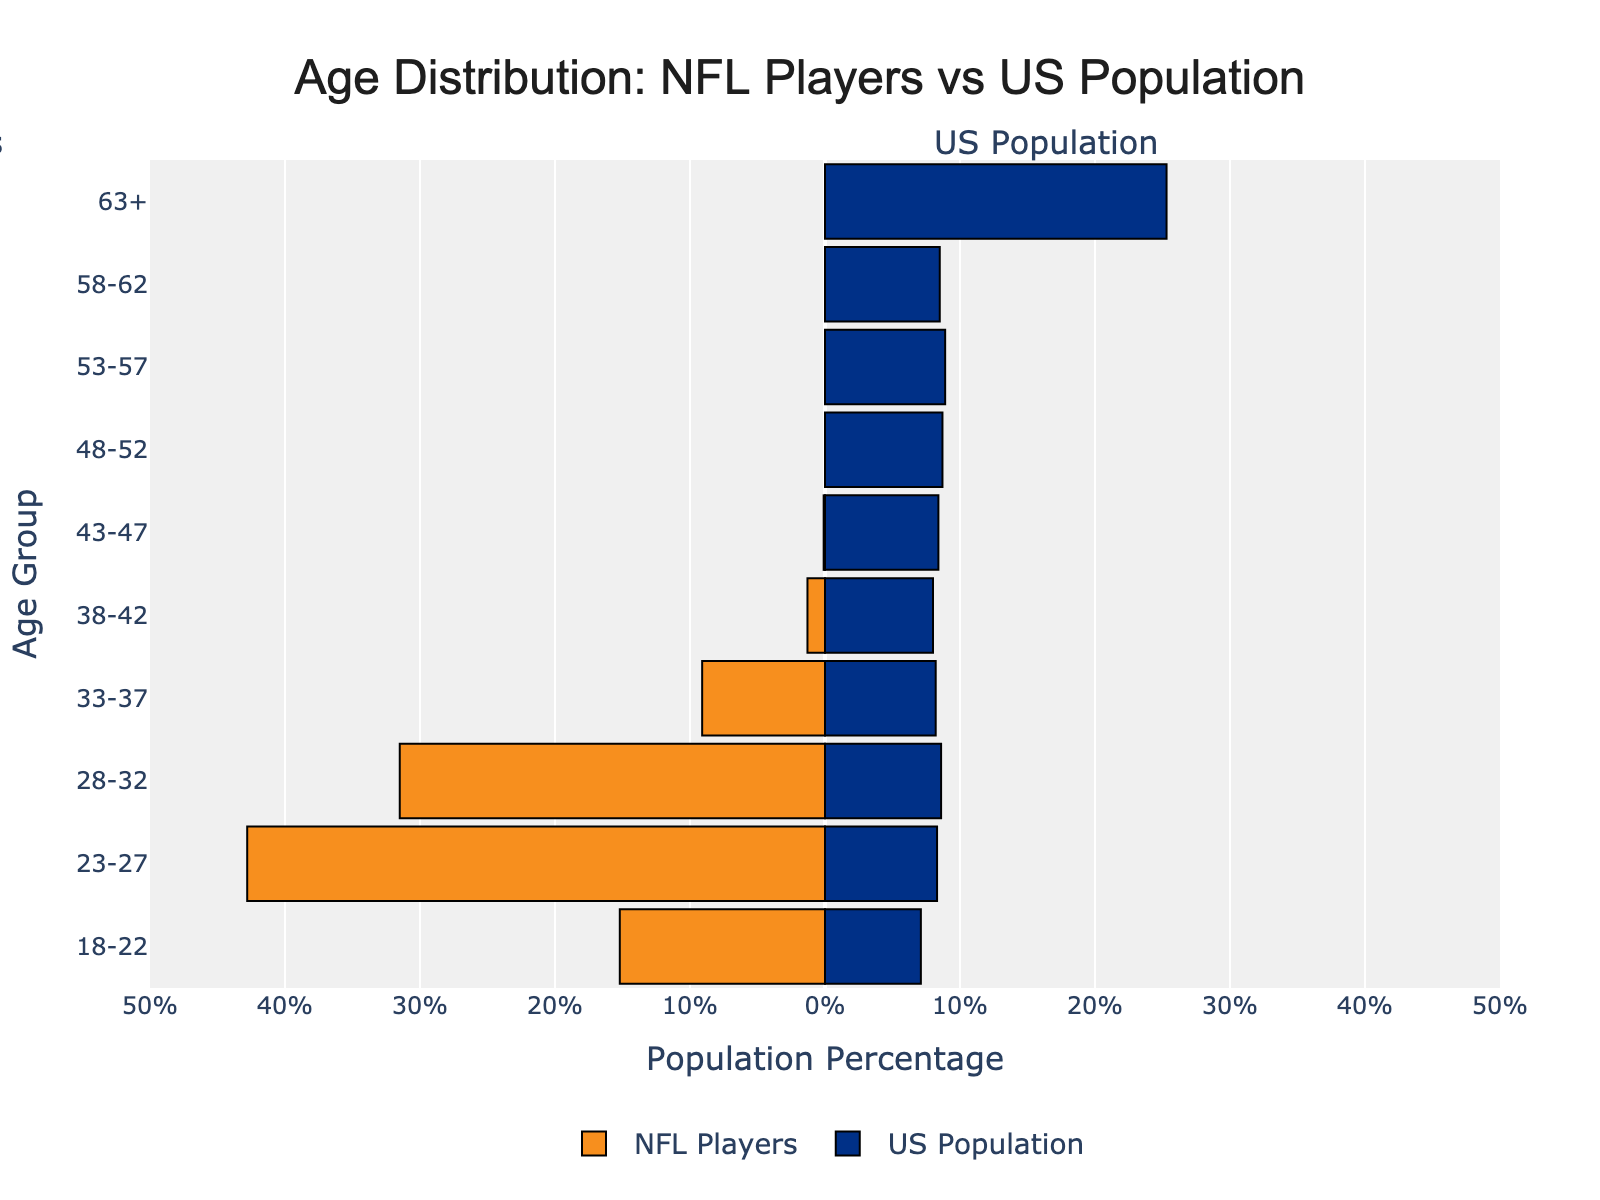What is the title of the figure? The title is typically found at the top-center of the figure. In this case, it reads 'Age Distribution: NFL Players vs US Population'.
Answer: Age Distribution: NFL Players vs US Population Which age group has the highest percentage of NFL players? By examining the bars representing 'NFL Players', the longest bar is in the '23-27' age group.
Answer: 23-27 How does the percentage of NFL Players in the '23-27' group compare to the same age group in the US Population? Look at the lengths of the bars representing '23-27' for both NFL Players and US Population. The NFL bar is significantly longer at 42.8%, while the US Population is only 8.3%.
Answer: Higher What percentage of NFL Players are in the '28-32' age group? Refer to the bar labeled '28-32' under 'NFL Players'. The x-axis value indicates 31.5%.
Answer: 31.5% Which group has a higher percentage of individuals aged 33-37, NFL Players or the US Population? Compare the bars for the '33-37' age group. The NFL Players bar is at 9.1% while the US Population bar is 8.2%.
Answer: NFL Players What age group has the lowest representation among NFL Players? Examine the left bars and note which age groups have the shortest or no visible bar. '48-52', '53-57', '58-62', and '63+' all have 0%.
Answer: 48-52, 53-57, 58-62, 63+ What is the combined percentage of NFL Players aged 33-37 and 38-42? Add the percentages shown for '33-37' (9.1%) and '38-42' (1.3%).
Answer: 10.4% How much larger is the percentage of NFL Players aged 18-22 compared to the same age group in the US Population? Subtract the percentage of the US Population from the NFL Players percentage for the '18-22' group: 15.2% - 7.1% = 8.1%.
Answer: 8.1% For which age groups does the US Population have a significantly higher percentage than NFL Players? Identify where US Population bars significantly exceed NFL Players bars. These are '38-42', '43-47', '48-52', '53-57', '58-62', and '63+'.
Answer: 38-42, 43-47, 48-52, 53-57, 58-62, 63+ Explain the overall pattern of age distribution for NFL players compared to the general US population. NFL Players are concentrated in younger age groups (18-32) with minimal representation above 37. In contrast, the general US population has a more even distribution across age groups with higher percentages in older age groups. This reflects the physically demanding nature of NFL careers.
Answer: Younger for NFL players, more even for US population 